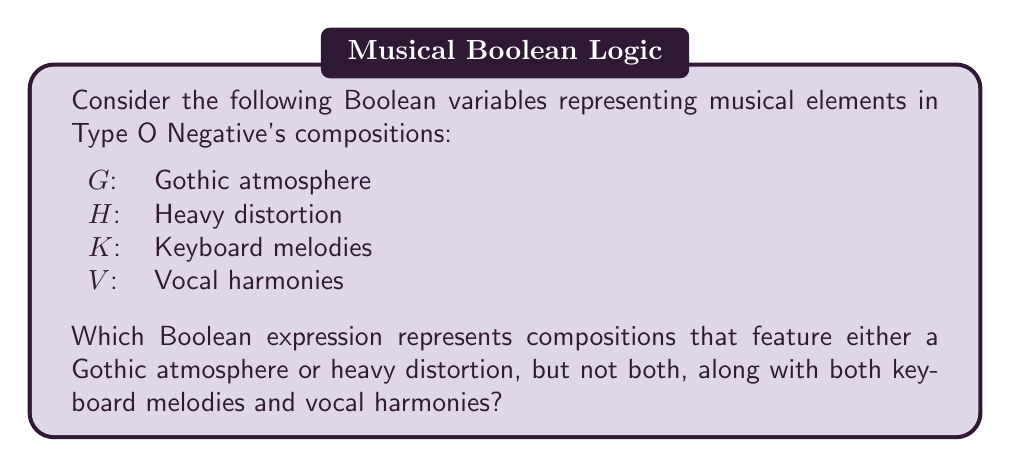Help me with this question. To solve this problem, we need to break it down into steps:

1. First, let's consider the requirement for either Gothic atmosphere or heavy distortion, but not both. This is an exclusive OR (XOR) operation, which can be represented as:

   $$(G \oplus H)$$

2. Next, we need to include both keyboard melodies and vocal harmonies. This is a logical AND operation:

   $$(K \wedge V)$$

3. Finally, we need to combine these two conditions using another logical AND operation:

   $$(G \oplus H) \wedge (K \wedge V)$$

4. We can simplify this expression slightly by removing the parentheses around $(K \wedge V)$ as the AND operation is associative:

   $$(G \oplus H) \wedge K \wedge V$$

This Boolean expression accurately represents Type O Negative compositions that feature either a Gothic atmosphere or heavy distortion (but not both), along with both keyboard melodies and vocal harmonies.
Answer: $$(G \oplus H) \wedge K \wedge V$$ 